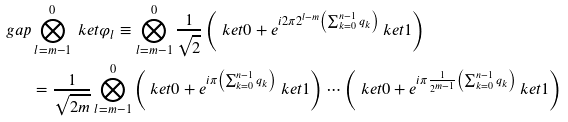Convert formula to latex. <formula><loc_0><loc_0><loc_500><loc_500>\ g a p & \bigotimes _ { l = m - 1 } ^ { 0 } \ k e t { \varphi _ { l } } \equiv \bigotimes _ { l = m - 1 } ^ { 0 } \frac { 1 } { \sqrt { 2 } } \left ( \ k e t { 0 } + e ^ { i 2 \pi 2 ^ { l - m } \left ( \sum _ { k = 0 } ^ { n - 1 } q _ { k } \right ) } \ k e t { 1 } \right ) \\ & = \frac { 1 } { \sqrt { 2 m } } \bigotimes _ { l = m - 1 } ^ { 0 } \left ( \ k e t { 0 } + e ^ { i \pi \left ( \sum _ { k = 0 } ^ { n - 1 } q _ { k } \right ) } \ k e t { 1 } \right ) \cdots \left ( \ k e t { 0 } + e ^ { i \pi \frac { 1 } { 2 ^ { m - 1 } } \left ( \sum _ { k = 0 } ^ { n - 1 } q _ { k } \right ) } \ k e t { 1 } \right )</formula> 